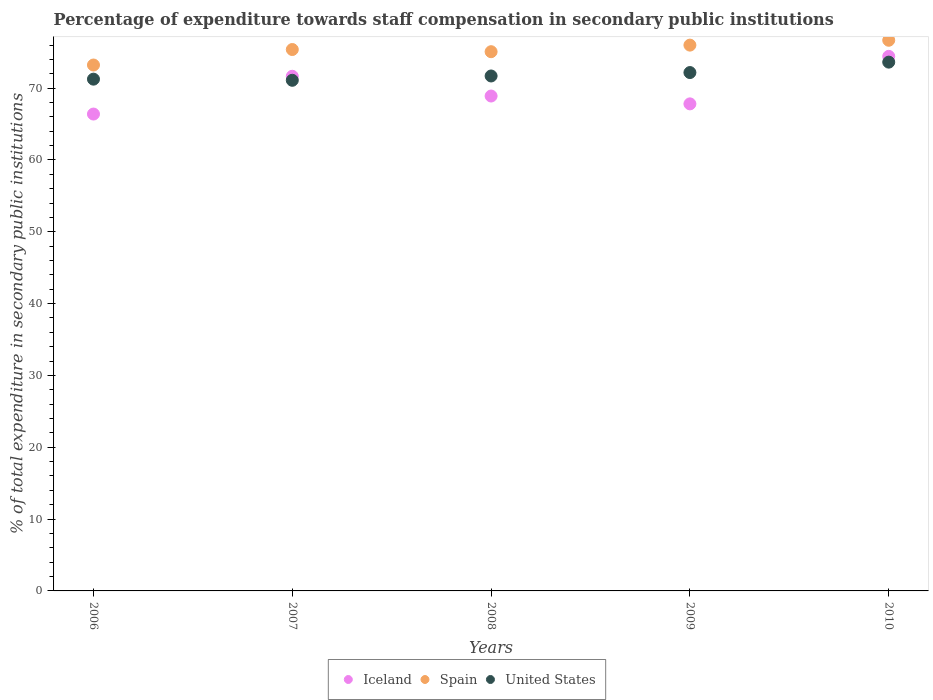Is the number of dotlines equal to the number of legend labels?
Offer a terse response. Yes. What is the percentage of expenditure towards staff compensation in Spain in 2008?
Offer a very short reply. 75.07. Across all years, what is the maximum percentage of expenditure towards staff compensation in Spain?
Your response must be concise. 76.66. Across all years, what is the minimum percentage of expenditure towards staff compensation in Spain?
Keep it short and to the point. 73.21. What is the total percentage of expenditure towards staff compensation in United States in the graph?
Your answer should be very brief. 359.8. What is the difference between the percentage of expenditure towards staff compensation in United States in 2006 and that in 2007?
Ensure brevity in your answer.  0.16. What is the difference between the percentage of expenditure towards staff compensation in Iceland in 2006 and the percentage of expenditure towards staff compensation in Spain in 2008?
Offer a very short reply. -8.68. What is the average percentage of expenditure towards staff compensation in Spain per year?
Give a very brief answer. 75.26. In the year 2009, what is the difference between the percentage of expenditure towards staff compensation in Iceland and percentage of expenditure towards staff compensation in Spain?
Provide a short and direct response. -8.18. In how many years, is the percentage of expenditure towards staff compensation in Spain greater than 42 %?
Keep it short and to the point. 5. What is the ratio of the percentage of expenditure towards staff compensation in Iceland in 2007 to that in 2010?
Your answer should be compact. 0.96. Is the percentage of expenditure towards staff compensation in Spain in 2008 less than that in 2010?
Make the answer very short. Yes. What is the difference between the highest and the second highest percentage of expenditure towards staff compensation in Spain?
Your response must be concise. 0.68. What is the difference between the highest and the lowest percentage of expenditure towards staff compensation in United States?
Your answer should be compact. 2.53. Is the sum of the percentage of expenditure towards staff compensation in United States in 2008 and 2009 greater than the maximum percentage of expenditure towards staff compensation in Iceland across all years?
Give a very brief answer. Yes. Does the percentage of expenditure towards staff compensation in Spain monotonically increase over the years?
Offer a terse response. No. Is the percentage of expenditure towards staff compensation in Iceland strictly greater than the percentage of expenditure towards staff compensation in United States over the years?
Offer a very short reply. No. Is the percentage of expenditure towards staff compensation in United States strictly less than the percentage of expenditure towards staff compensation in Iceland over the years?
Give a very brief answer. No. What is the difference between two consecutive major ticks on the Y-axis?
Provide a short and direct response. 10. Does the graph contain grids?
Ensure brevity in your answer.  No. Where does the legend appear in the graph?
Offer a very short reply. Bottom center. How many legend labels are there?
Give a very brief answer. 3. How are the legend labels stacked?
Ensure brevity in your answer.  Horizontal. What is the title of the graph?
Your answer should be very brief. Percentage of expenditure towards staff compensation in secondary public institutions. What is the label or title of the X-axis?
Ensure brevity in your answer.  Years. What is the label or title of the Y-axis?
Offer a terse response. % of total expenditure in secondary public institutions. What is the % of total expenditure in secondary public institutions of Iceland in 2006?
Make the answer very short. 66.39. What is the % of total expenditure in secondary public institutions in Spain in 2006?
Your answer should be very brief. 73.21. What is the % of total expenditure in secondary public institutions of United States in 2006?
Offer a terse response. 71.25. What is the % of total expenditure in secondary public institutions of Iceland in 2007?
Give a very brief answer. 71.65. What is the % of total expenditure in secondary public institutions of Spain in 2007?
Your answer should be compact. 75.37. What is the % of total expenditure in secondary public institutions of United States in 2007?
Give a very brief answer. 71.09. What is the % of total expenditure in secondary public institutions in Iceland in 2008?
Provide a short and direct response. 68.9. What is the % of total expenditure in secondary public institutions of Spain in 2008?
Ensure brevity in your answer.  75.07. What is the % of total expenditure in secondary public institutions of United States in 2008?
Keep it short and to the point. 71.69. What is the % of total expenditure in secondary public institutions in Iceland in 2009?
Your answer should be very brief. 67.81. What is the % of total expenditure in secondary public institutions of Spain in 2009?
Your response must be concise. 75.98. What is the % of total expenditure in secondary public institutions of United States in 2009?
Provide a succinct answer. 72.17. What is the % of total expenditure in secondary public institutions in Iceland in 2010?
Your answer should be very brief. 74.42. What is the % of total expenditure in secondary public institutions of Spain in 2010?
Your answer should be very brief. 76.66. What is the % of total expenditure in secondary public institutions in United States in 2010?
Make the answer very short. 73.62. Across all years, what is the maximum % of total expenditure in secondary public institutions of Iceland?
Make the answer very short. 74.42. Across all years, what is the maximum % of total expenditure in secondary public institutions in Spain?
Keep it short and to the point. 76.66. Across all years, what is the maximum % of total expenditure in secondary public institutions in United States?
Your answer should be very brief. 73.62. Across all years, what is the minimum % of total expenditure in secondary public institutions in Iceland?
Provide a succinct answer. 66.39. Across all years, what is the minimum % of total expenditure in secondary public institutions in Spain?
Your answer should be compact. 73.21. Across all years, what is the minimum % of total expenditure in secondary public institutions in United States?
Offer a very short reply. 71.09. What is the total % of total expenditure in secondary public institutions of Iceland in the graph?
Give a very brief answer. 349.16. What is the total % of total expenditure in secondary public institutions of Spain in the graph?
Your answer should be compact. 376.3. What is the total % of total expenditure in secondary public institutions in United States in the graph?
Keep it short and to the point. 359.8. What is the difference between the % of total expenditure in secondary public institutions of Iceland in 2006 and that in 2007?
Make the answer very short. -5.26. What is the difference between the % of total expenditure in secondary public institutions of Spain in 2006 and that in 2007?
Provide a succinct answer. -2.16. What is the difference between the % of total expenditure in secondary public institutions in United States in 2006 and that in 2007?
Provide a short and direct response. 0.16. What is the difference between the % of total expenditure in secondary public institutions of Iceland in 2006 and that in 2008?
Provide a succinct answer. -2.51. What is the difference between the % of total expenditure in secondary public institutions of Spain in 2006 and that in 2008?
Make the answer very short. -1.85. What is the difference between the % of total expenditure in secondary public institutions of United States in 2006 and that in 2008?
Make the answer very short. -0.44. What is the difference between the % of total expenditure in secondary public institutions of Iceland in 2006 and that in 2009?
Your answer should be compact. -1.42. What is the difference between the % of total expenditure in secondary public institutions of Spain in 2006 and that in 2009?
Your response must be concise. -2.77. What is the difference between the % of total expenditure in secondary public institutions of United States in 2006 and that in 2009?
Your response must be concise. -0.92. What is the difference between the % of total expenditure in secondary public institutions in Iceland in 2006 and that in 2010?
Your answer should be very brief. -8.03. What is the difference between the % of total expenditure in secondary public institutions in Spain in 2006 and that in 2010?
Offer a very short reply. -3.45. What is the difference between the % of total expenditure in secondary public institutions of United States in 2006 and that in 2010?
Give a very brief answer. -2.37. What is the difference between the % of total expenditure in secondary public institutions in Iceland in 2007 and that in 2008?
Offer a terse response. 2.75. What is the difference between the % of total expenditure in secondary public institutions of Spain in 2007 and that in 2008?
Offer a very short reply. 0.3. What is the difference between the % of total expenditure in secondary public institutions of United States in 2007 and that in 2008?
Keep it short and to the point. -0.6. What is the difference between the % of total expenditure in secondary public institutions in Iceland in 2007 and that in 2009?
Make the answer very short. 3.84. What is the difference between the % of total expenditure in secondary public institutions in Spain in 2007 and that in 2009?
Ensure brevity in your answer.  -0.61. What is the difference between the % of total expenditure in secondary public institutions of United States in 2007 and that in 2009?
Your answer should be compact. -1.08. What is the difference between the % of total expenditure in secondary public institutions of Iceland in 2007 and that in 2010?
Your answer should be compact. -2.78. What is the difference between the % of total expenditure in secondary public institutions of Spain in 2007 and that in 2010?
Your answer should be compact. -1.29. What is the difference between the % of total expenditure in secondary public institutions in United States in 2007 and that in 2010?
Provide a short and direct response. -2.53. What is the difference between the % of total expenditure in secondary public institutions of Iceland in 2008 and that in 2009?
Keep it short and to the point. 1.09. What is the difference between the % of total expenditure in secondary public institutions of Spain in 2008 and that in 2009?
Your answer should be very brief. -0.92. What is the difference between the % of total expenditure in secondary public institutions of United States in 2008 and that in 2009?
Provide a succinct answer. -0.48. What is the difference between the % of total expenditure in secondary public institutions in Iceland in 2008 and that in 2010?
Your response must be concise. -5.52. What is the difference between the % of total expenditure in secondary public institutions of Spain in 2008 and that in 2010?
Make the answer very short. -1.59. What is the difference between the % of total expenditure in secondary public institutions in United States in 2008 and that in 2010?
Ensure brevity in your answer.  -1.93. What is the difference between the % of total expenditure in secondary public institutions in Iceland in 2009 and that in 2010?
Ensure brevity in your answer.  -6.62. What is the difference between the % of total expenditure in secondary public institutions in Spain in 2009 and that in 2010?
Offer a very short reply. -0.68. What is the difference between the % of total expenditure in secondary public institutions in United States in 2009 and that in 2010?
Provide a short and direct response. -1.45. What is the difference between the % of total expenditure in secondary public institutions in Iceland in 2006 and the % of total expenditure in secondary public institutions in Spain in 2007?
Make the answer very short. -8.98. What is the difference between the % of total expenditure in secondary public institutions of Iceland in 2006 and the % of total expenditure in secondary public institutions of United States in 2007?
Your answer should be compact. -4.7. What is the difference between the % of total expenditure in secondary public institutions in Spain in 2006 and the % of total expenditure in secondary public institutions in United States in 2007?
Your answer should be very brief. 2.13. What is the difference between the % of total expenditure in secondary public institutions of Iceland in 2006 and the % of total expenditure in secondary public institutions of Spain in 2008?
Your answer should be very brief. -8.68. What is the difference between the % of total expenditure in secondary public institutions in Iceland in 2006 and the % of total expenditure in secondary public institutions in United States in 2008?
Provide a short and direct response. -5.3. What is the difference between the % of total expenditure in secondary public institutions in Spain in 2006 and the % of total expenditure in secondary public institutions in United States in 2008?
Your answer should be very brief. 1.53. What is the difference between the % of total expenditure in secondary public institutions in Iceland in 2006 and the % of total expenditure in secondary public institutions in Spain in 2009?
Offer a very short reply. -9.6. What is the difference between the % of total expenditure in secondary public institutions in Iceland in 2006 and the % of total expenditure in secondary public institutions in United States in 2009?
Make the answer very short. -5.78. What is the difference between the % of total expenditure in secondary public institutions in Spain in 2006 and the % of total expenditure in secondary public institutions in United States in 2009?
Provide a short and direct response. 1.05. What is the difference between the % of total expenditure in secondary public institutions of Iceland in 2006 and the % of total expenditure in secondary public institutions of Spain in 2010?
Provide a short and direct response. -10.27. What is the difference between the % of total expenditure in secondary public institutions in Iceland in 2006 and the % of total expenditure in secondary public institutions in United States in 2010?
Make the answer very short. -7.23. What is the difference between the % of total expenditure in secondary public institutions of Spain in 2006 and the % of total expenditure in secondary public institutions of United States in 2010?
Offer a very short reply. -0.4. What is the difference between the % of total expenditure in secondary public institutions of Iceland in 2007 and the % of total expenditure in secondary public institutions of Spain in 2008?
Provide a short and direct response. -3.42. What is the difference between the % of total expenditure in secondary public institutions of Iceland in 2007 and the % of total expenditure in secondary public institutions of United States in 2008?
Provide a short and direct response. -0.04. What is the difference between the % of total expenditure in secondary public institutions of Spain in 2007 and the % of total expenditure in secondary public institutions of United States in 2008?
Your answer should be very brief. 3.68. What is the difference between the % of total expenditure in secondary public institutions in Iceland in 2007 and the % of total expenditure in secondary public institutions in Spain in 2009?
Provide a short and direct response. -4.34. What is the difference between the % of total expenditure in secondary public institutions in Iceland in 2007 and the % of total expenditure in secondary public institutions in United States in 2009?
Provide a short and direct response. -0.52. What is the difference between the % of total expenditure in secondary public institutions of Spain in 2007 and the % of total expenditure in secondary public institutions of United States in 2009?
Make the answer very short. 3.21. What is the difference between the % of total expenditure in secondary public institutions in Iceland in 2007 and the % of total expenditure in secondary public institutions in Spain in 2010?
Ensure brevity in your answer.  -5.01. What is the difference between the % of total expenditure in secondary public institutions of Iceland in 2007 and the % of total expenditure in secondary public institutions of United States in 2010?
Keep it short and to the point. -1.97. What is the difference between the % of total expenditure in secondary public institutions of Spain in 2007 and the % of total expenditure in secondary public institutions of United States in 2010?
Ensure brevity in your answer.  1.76. What is the difference between the % of total expenditure in secondary public institutions in Iceland in 2008 and the % of total expenditure in secondary public institutions in Spain in 2009?
Your answer should be very brief. -7.09. What is the difference between the % of total expenditure in secondary public institutions of Iceland in 2008 and the % of total expenditure in secondary public institutions of United States in 2009?
Your answer should be very brief. -3.27. What is the difference between the % of total expenditure in secondary public institutions of Spain in 2008 and the % of total expenditure in secondary public institutions of United States in 2009?
Provide a short and direct response. 2.9. What is the difference between the % of total expenditure in secondary public institutions of Iceland in 2008 and the % of total expenditure in secondary public institutions of Spain in 2010?
Offer a very short reply. -7.76. What is the difference between the % of total expenditure in secondary public institutions of Iceland in 2008 and the % of total expenditure in secondary public institutions of United States in 2010?
Keep it short and to the point. -4.72. What is the difference between the % of total expenditure in secondary public institutions in Spain in 2008 and the % of total expenditure in secondary public institutions in United States in 2010?
Offer a very short reply. 1.45. What is the difference between the % of total expenditure in secondary public institutions of Iceland in 2009 and the % of total expenditure in secondary public institutions of Spain in 2010?
Provide a succinct answer. -8.85. What is the difference between the % of total expenditure in secondary public institutions of Iceland in 2009 and the % of total expenditure in secondary public institutions of United States in 2010?
Make the answer very short. -5.81. What is the difference between the % of total expenditure in secondary public institutions of Spain in 2009 and the % of total expenditure in secondary public institutions of United States in 2010?
Ensure brevity in your answer.  2.37. What is the average % of total expenditure in secondary public institutions in Iceland per year?
Your response must be concise. 69.83. What is the average % of total expenditure in secondary public institutions of Spain per year?
Keep it short and to the point. 75.26. What is the average % of total expenditure in secondary public institutions in United States per year?
Your answer should be very brief. 71.96. In the year 2006, what is the difference between the % of total expenditure in secondary public institutions of Iceland and % of total expenditure in secondary public institutions of Spain?
Give a very brief answer. -6.83. In the year 2006, what is the difference between the % of total expenditure in secondary public institutions of Iceland and % of total expenditure in secondary public institutions of United States?
Your answer should be compact. -4.86. In the year 2006, what is the difference between the % of total expenditure in secondary public institutions in Spain and % of total expenditure in secondary public institutions in United States?
Give a very brief answer. 1.97. In the year 2007, what is the difference between the % of total expenditure in secondary public institutions in Iceland and % of total expenditure in secondary public institutions in Spain?
Make the answer very short. -3.73. In the year 2007, what is the difference between the % of total expenditure in secondary public institutions in Iceland and % of total expenditure in secondary public institutions in United States?
Ensure brevity in your answer.  0.56. In the year 2007, what is the difference between the % of total expenditure in secondary public institutions in Spain and % of total expenditure in secondary public institutions in United States?
Keep it short and to the point. 4.28. In the year 2008, what is the difference between the % of total expenditure in secondary public institutions in Iceland and % of total expenditure in secondary public institutions in Spain?
Provide a succinct answer. -6.17. In the year 2008, what is the difference between the % of total expenditure in secondary public institutions in Iceland and % of total expenditure in secondary public institutions in United States?
Ensure brevity in your answer.  -2.79. In the year 2008, what is the difference between the % of total expenditure in secondary public institutions of Spain and % of total expenditure in secondary public institutions of United States?
Your response must be concise. 3.38. In the year 2009, what is the difference between the % of total expenditure in secondary public institutions in Iceland and % of total expenditure in secondary public institutions in Spain?
Offer a very short reply. -8.18. In the year 2009, what is the difference between the % of total expenditure in secondary public institutions in Iceland and % of total expenditure in secondary public institutions in United States?
Give a very brief answer. -4.36. In the year 2009, what is the difference between the % of total expenditure in secondary public institutions of Spain and % of total expenditure in secondary public institutions of United States?
Ensure brevity in your answer.  3.82. In the year 2010, what is the difference between the % of total expenditure in secondary public institutions of Iceland and % of total expenditure in secondary public institutions of Spain?
Offer a very short reply. -2.24. In the year 2010, what is the difference between the % of total expenditure in secondary public institutions of Iceland and % of total expenditure in secondary public institutions of United States?
Your answer should be very brief. 0.81. In the year 2010, what is the difference between the % of total expenditure in secondary public institutions of Spain and % of total expenditure in secondary public institutions of United States?
Offer a terse response. 3.04. What is the ratio of the % of total expenditure in secondary public institutions in Iceland in 2006 to that in 2007?
Your response must be concise. 0.93. What is the ratio of the % of total expenditure in secondary public institutions of Spain in 2006 to that in 2007?
Your answer should be very brief. 0.97. What is the ratio of the % of total expenditure in secondary public institutions in United States in 2006 to that in 2007?
Make the answer very short. 1. What is the ratio of the % of total expenditure in secondary public institutions in Iceland in 2006 to that in 2008?
Give a very brief answer. 0.96. What is the ratio of the % of total expenditure in secondary public institutions in Spain in 2006 to that in 2008?
Make the answer very short. 0.98. What is the ratio of the % of total expenditure in secondary public institutions in Iceland in 2006 to that in 2009?
Provide a short and direct response. 0.98. What is the ratio of the % of total expenditure in secondary public institutions in Spain in 2006 to that in 2009?
Give a very brief answer. 0.96. What is the ratio of the % of total expenditure in secondary public institutions of United States in 2006 to that in 2009?
Make the answer very short. 0.99. What is the ratio of the % of total expenditure in secondary public institutions in Iceland in 2006 to that in 2010?
Your answer should be compact. 0.89. What is the ratio of the % of total expenditure in secondary public institutions in Spain in 2006 to that in 2010?
Your response must be concise. 0.95. What is the ratio of the % of total expenditure in secondary public institutions in United States in 2006 to that in 2010?
Offer a very short reply. 0.97. What is the ratio of the % of total expenditure in secondary public institutions in Iceland in 2007 to that in 2008?
Your response must be concise. 1.04. What is the ratio of the % of total expenditure in secondary public institutions in United States in 2007 to that in 2008?
Ensure brevity in your answer.  0.99. What is the ratio of the % of total expenditure in secondary public institutions of Iceland in 2007 to that in 2009?
Ensure brevity in your answer.  1.06. What is the ratio of the % of total expenditure in secondary public institutions of Spain in 2007 to that in 2009?
Ensure brevity in your answer.  0.99. What is the ratio of the % of total expenditure in secondary public institutions of United States in 2007 to that in 2009?
Your answer should be very brief. 0.99. What is the ratio of the % of total expenditure in secondary public institutions in Iceland in 2007 to that in 2010?
Your answer should be very brief. 0.96. What is the ratio of the % of total expenditure in secondary public institutions of Spain in 2007 to that in 2010?
Keep it short and to the point. 0.98. What is the ratio of the % of total expenditure in secondary public institutions of United States in 2007 to that in 2010?
Make the answer very short. 0.97. What is the ratio of the % of total expenditure in secondary public institutions in Iceland in 2008 to that in 2009?
Offer a very short reply. 1.02. What is the ratio of the % of total expenditure in secondary public institutions of Spain in 2008 to that in 2009?
Provide a succinct answer. 0.99. What is the ratio of the % of total expenditure in secondary public institutions in Iceland in 2008 to that in 2010?
Give a very brief answer. 0.93. What is the ratio of the % of total expenditure in secondary public institutions in Spain in 2008 to that in 2010?
Your answer should be compact. 0.98. What is the ratio of the % of total expenditure in secondary public institutions of United States in 2008 to that in 2010?
Give a very brief answer. 0.97. What is the ratio of the % of total expenditure in secondary public institutions of Iceland in 2009 to that in 2010?
Offer a terse response. 0.91. What is the ratio of the % of total expenditure in secondary public institutions of United States in 2009 to that in 2010?
Provide a succinct answer. 0.98. What is the difference between the highest and the second highest % of total expenditure in secondary public institutions in Iceland?
Provide a succinct answer. 2.78. What is the difference between the highest and the second highest % of total expenditure in secondary public institutions in Spain?
Offer a very short reply. 0.68. What is the difference between the highest and the second highest % of total expenditure in secondary public institutions of United States?
Provide a succinct answer. 1.45. What is the difference between the highest and the lowest % of total expenditure in secondary public institutions of Iceland?
Provide a short and direct response. 8.03. What is the difference between the highest and the lowest % of total expenditure in secondary public institutions in Spain?
Your response must be concise. 3.45. What is the difference between the highest and the lowest % of total expenditure in secondary public institutions in United States?
Offer a terse response. 2.53. 